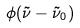Convert formula to latex. <formula><loc_0><loc_0><loc_500><loc_500>\phi ( \tilde { \nu } - \tilde { \nu } _ { 0 } )</formula> 